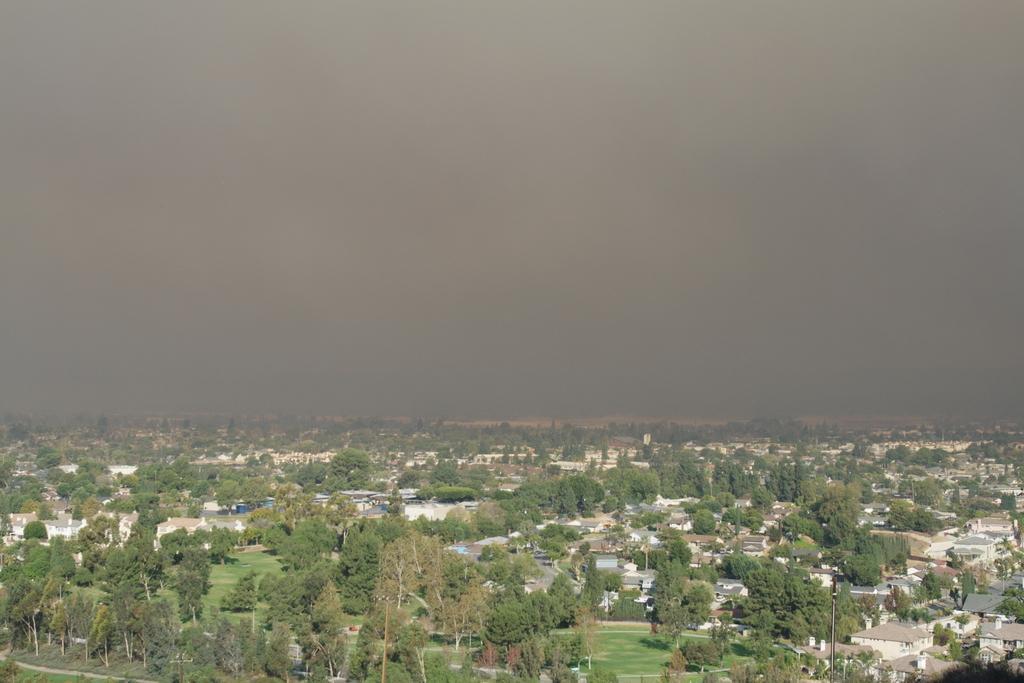Please provide a concise description of this image. In this image we can see the trees and buildings. And at the top we can see the sky. 